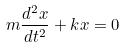<formula> <loc_0><loc_0><loc_500><loc_500>m \frac { d ^ { 2 } x } { d t ^ { 2 } } + k x = 0</formula> 